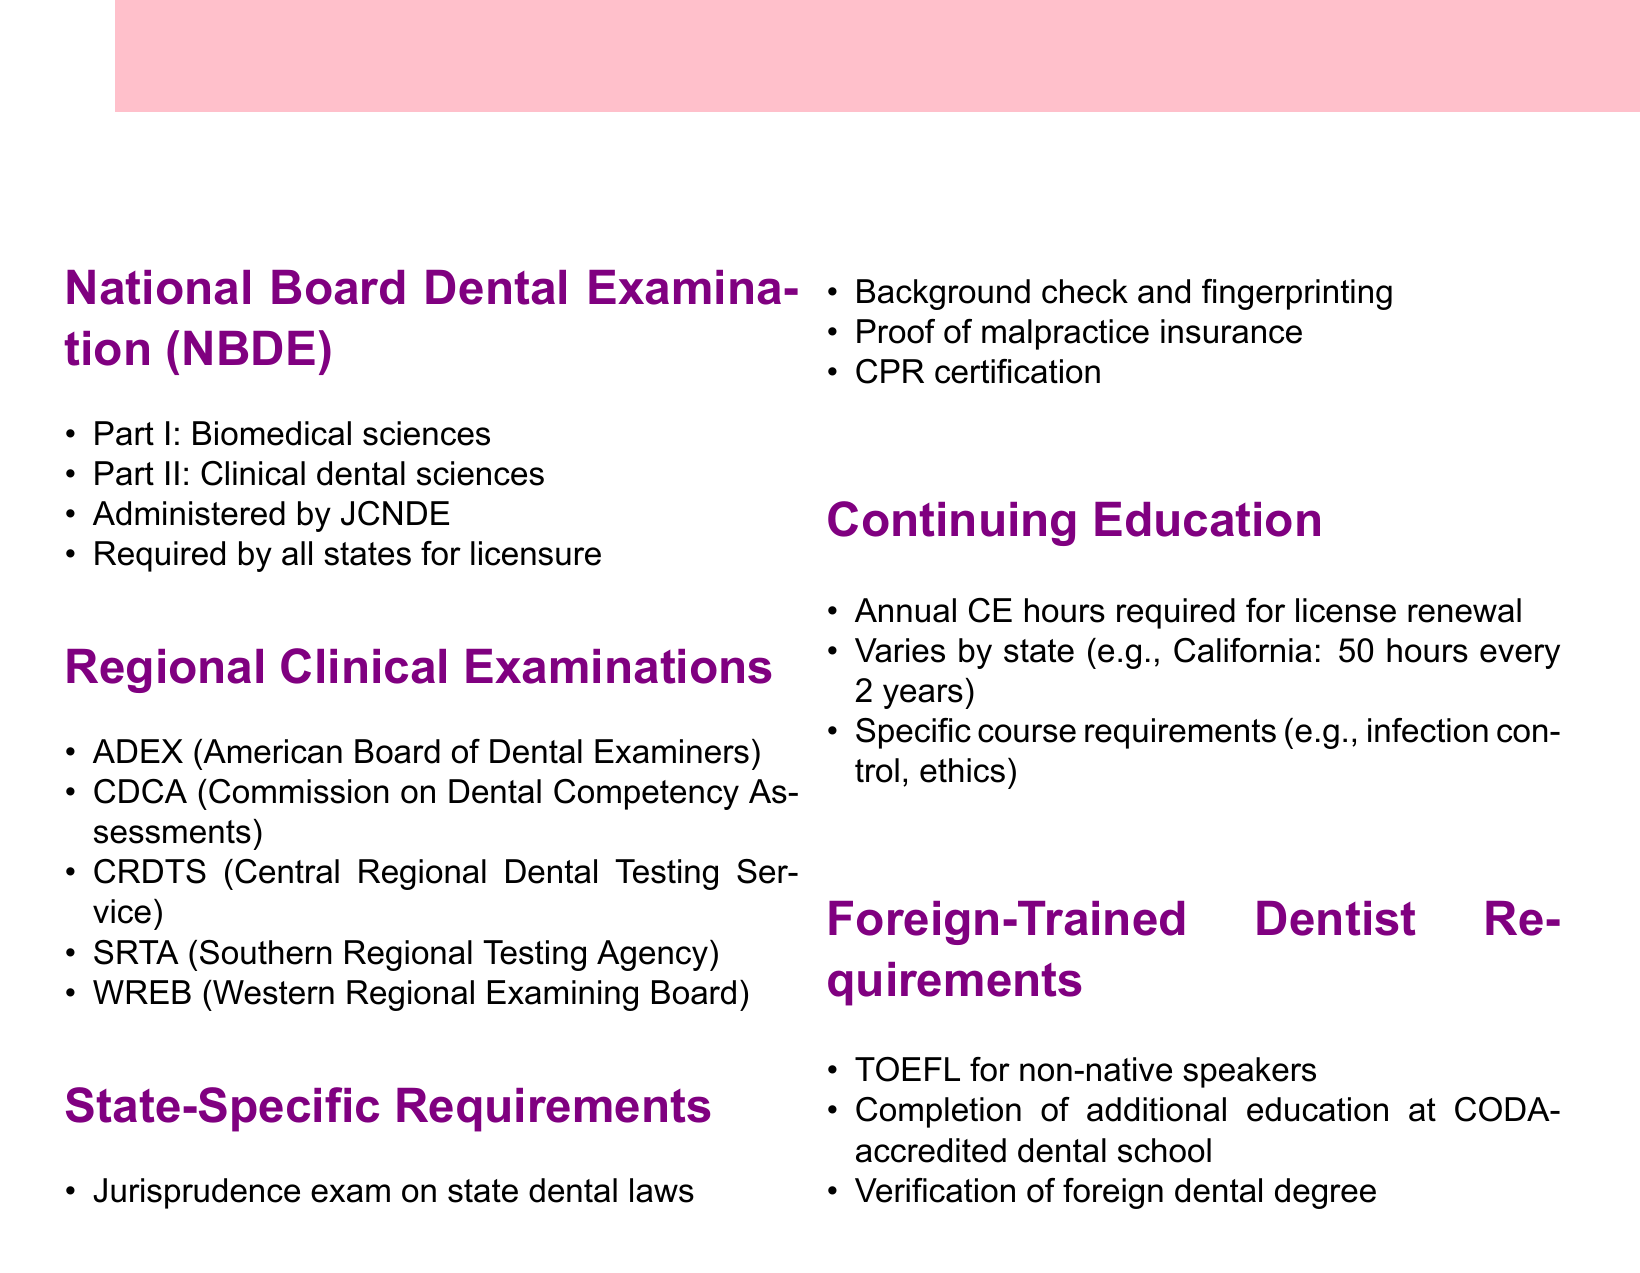What is the first part of the NBDE? The first part of the National Board Dental Examination is focused on biomedical sciences.
Answer: Biomedical sciences Which organization administers the NBDE? The National Board Dental Examination is administered by the Joint Commission on National Dental Examinations.
Answer: JCNDE What is one of the regional clinical examinations? Regional clinical examinations include multiple options, with one example being the ADEX.
Answer: ADEX What do most states require aside from exams for dental licensure? In addition to exams, states generally require background checks and fingerprinting.
Answer: Background check and fingerprinting How many CE hours are required in California for license renewal every two years? California requires a specific number of continuing education hours for license renewal every two years.
Answer: 50 hours What certification is generally required for dentists? Dentists are typically required to have certification in cardiopulmonary resuscitation.
Answer: CPR certification What must foreign-trained dentists provide for verification? Foreign-trained dentists must provide proof of their dental education by verifying their foreign dental degree.
Answer: Verification of foreign dental degree What is the TOEFL requirement for? The TOEFL is required for non-native speakers seeking dental licensure in the U.S.
Answer: Non-native speakers 